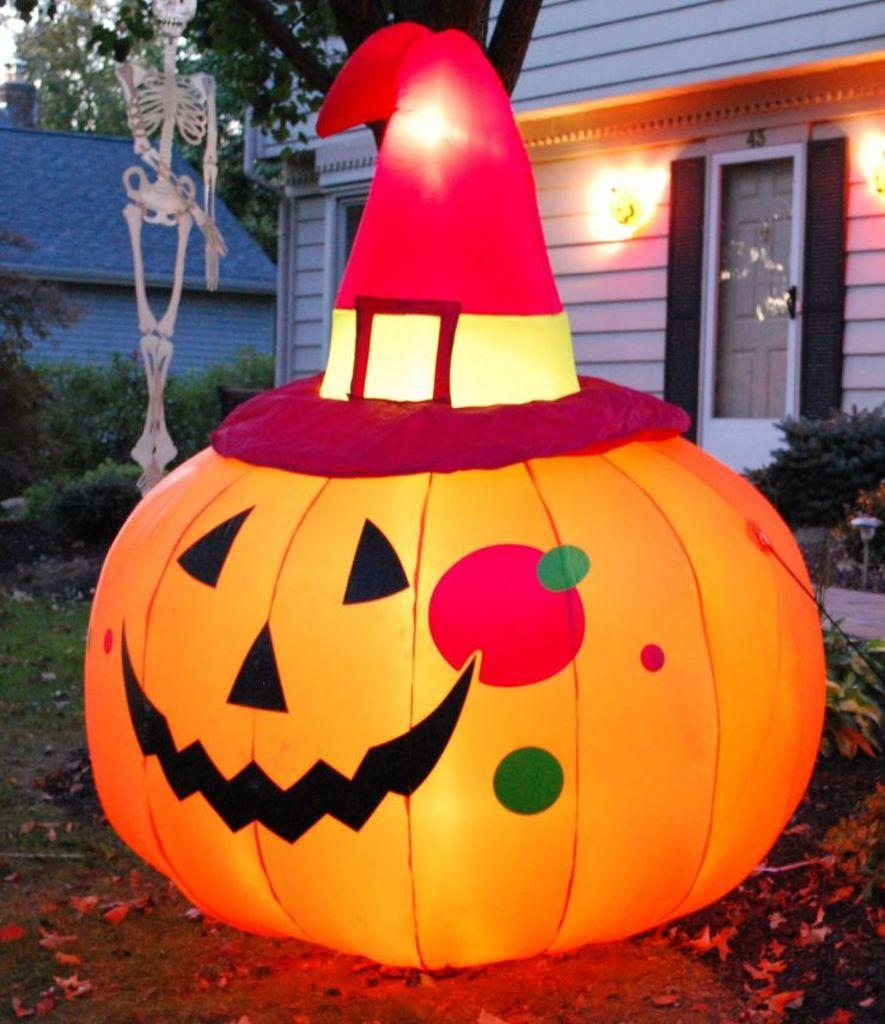What is the main subject in the center of the image? There is a pumpkin decoration in the center of the image. What can be seen in the background of the image? There is a shed, trees, a board, and bushes in the background of the image. What type of butter is being used to detail the pumpkin decoration in the image? There is no butter or detailing work visible on the pumpkin decoration in the image. 